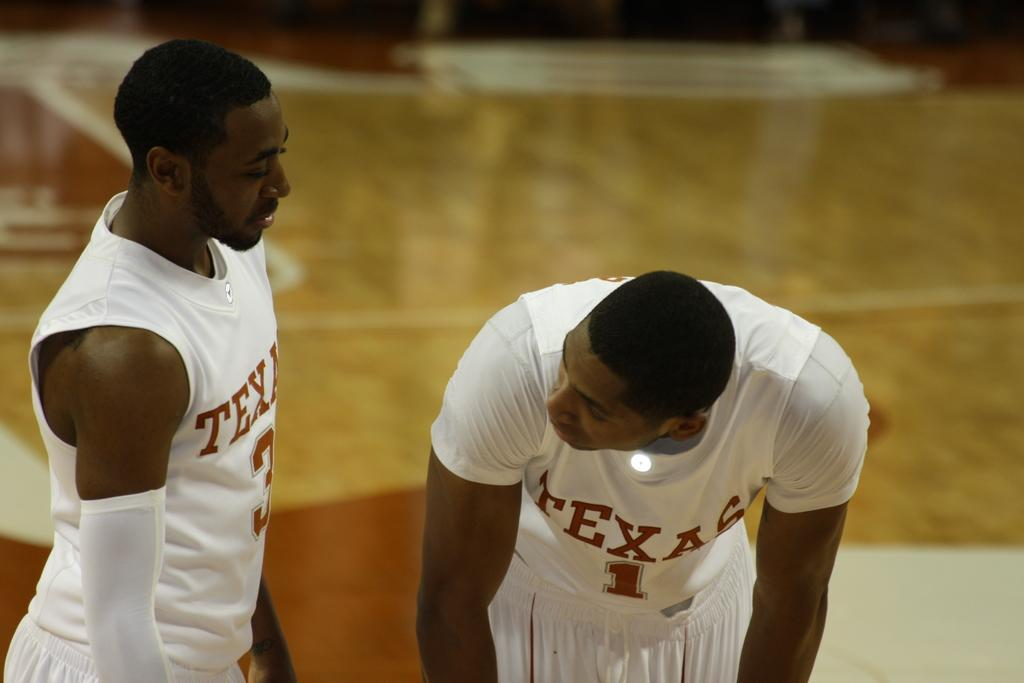Provide a one-sentence caption for the provided image. Two Texas basketball players wearing all white are seen talking to each other. 